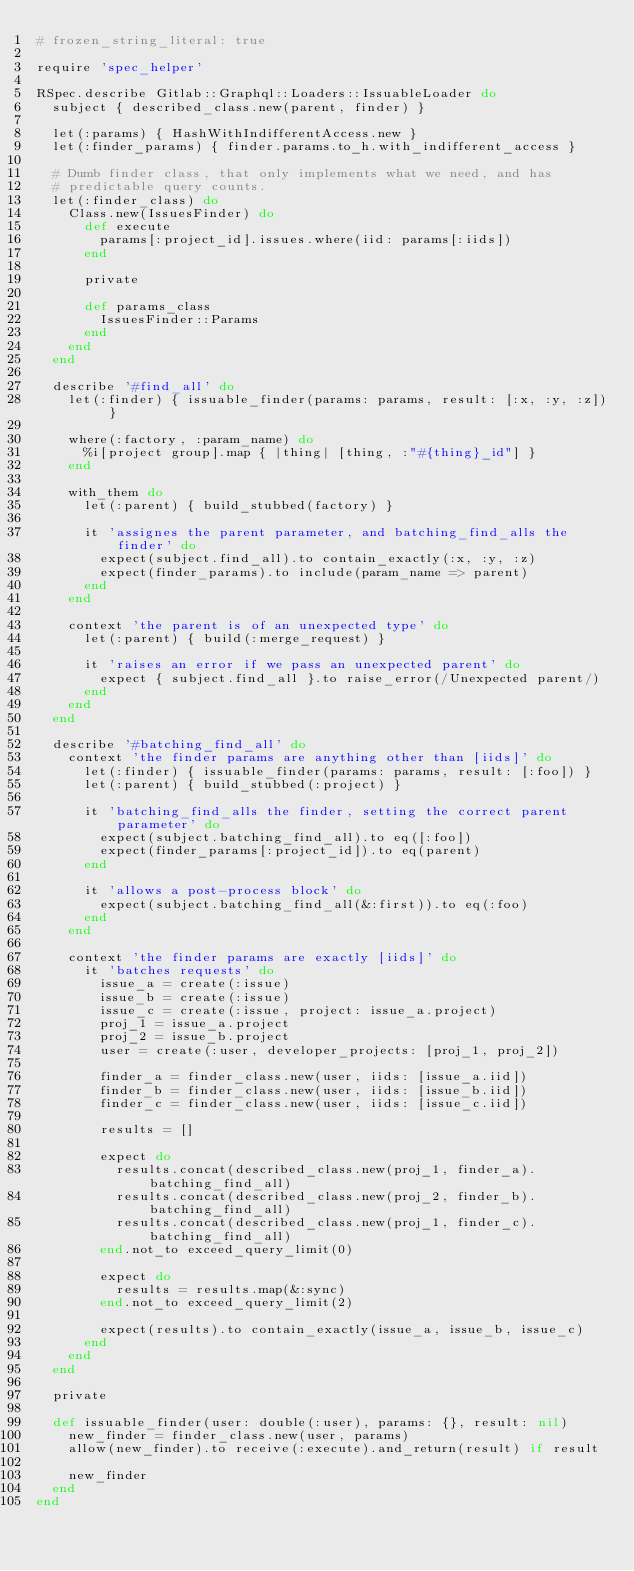Convert code to text. <code><loc_0><loc_0><loc_500><loc_500><_Ruby_># frozen_string_literal: true

require 'spec_helper'

RSpec.describe Gitlab::Graphql::Loaders::IssuableLoader do
  subject { described_class.new(parent, finder) }

  let(:params) { HashWithIndifferentAccess.new }
  let(:finder_params) { finder.params.to_h.with_indifferent_access }

  # Dumb finder class, that only implements what we need, and has
  # predictable query counts.
  let(:finder_class) do
    Class.new(IssuesFinder) do
      def execute
        params[:project_id].issues.where(iid: params[:iids])
      end

      private

      def params_class
        IssuesFinder::Params
      end
    end
  end

  describe '#find_all' do
    let(:finder) { issuable_finder(params: params, result: [:x, :y, :z]) }

    where(:factory, :param_name) do
      %i[project group].map { |thing| [thing, :"#{thing}_id"] }
    end

    with_them do
      let(:parent) { build_stubbed(factory) }

      it 'assignes the parent parameter, and batching_find_alls the finder' do
        expect(subject.find_all).to contain_exactly(:x, :y, :z)
        expect(finder_params).to include(param_name => parent)
      end
    end

    context 'the parent is of an unexpected type' do
      let(:parent) { build(:merge_request) }

      it 'raises an error if we pass an unexpected parent' do
        expect { subject.find_all }.to raise_error(/Unexpected parent/)
      end
    end
  end

  describe '#batching_find_all' do
    context 'the finder params are anything other than [iids]' do
      let(:finder) { issuable_finder(params: params, result: [:foo]) }
      let(:parent) { build_stubbed(:project) }

      it 'batching_find_alls the finder, setting the correct parent parameter' do
        expect(subject.batching_find_all).to eq([:foo])
        expect(finder_params[:project_id]).to eq(parent)
      end

      it 'allows a post-process block' do
        expect(subject.batching_find_all(&:first)).to eq(:foo)
      end
    end

    context 'the finder params are exactly [iids]' do
      it 'batches requests' do
        issue_a = create(:issue)
        issue_b = create(:issue)
        issue_c = create(:issue, project: issue_a.project)
        proj_1 = issue_a.project
        proj_2 = issue_b.project
        user = create(:user, developer_projects: [proj_1, proj_2])

        finder_a = finder_class.new(user, iids: [issue_a.iid])
        finder_b = finder_class.new(user, iids: [issue_b.iid])
        finder_c = finder_class.new(user, iids: [issue_c.iid])

        results = []

        expect do
          results.concat(described_class.new(proj_1, finder_a).batching_find_all)
          results.concat(described_class.new(proj_2, finder_b).batching_find_all)
          results.concat(described_class.new(proj_1, finder_c).batching_find_all)
        end.not_to exceed_query_limit(0)

        expect do
          results = results.map(&:sync)
        end.not_to exceed_query_limit(2)

        expect(results).to contain_exactly(issue_a, issue_b, issue_c)
      end
    end
  end

  private

  def issuable_finder(user: double(:user), params: {}, result: nil)
    new_finder = finder_class.new(user, params)
    allow(new_finder).to receive(:execute).and_return(result) if result

    new_finder
  end
end
</code> 